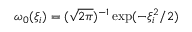Convert formula to latex. <formula><loc_0><loc_0><loc_500><loc_500>\omega _ { 0 } ( \xi _ { i } ) = ( \sqrt { 2 \pi } ) ^ { - 1 } \exp ( - \xi _ { i } ^ { 2 } / 2 )</formula> 